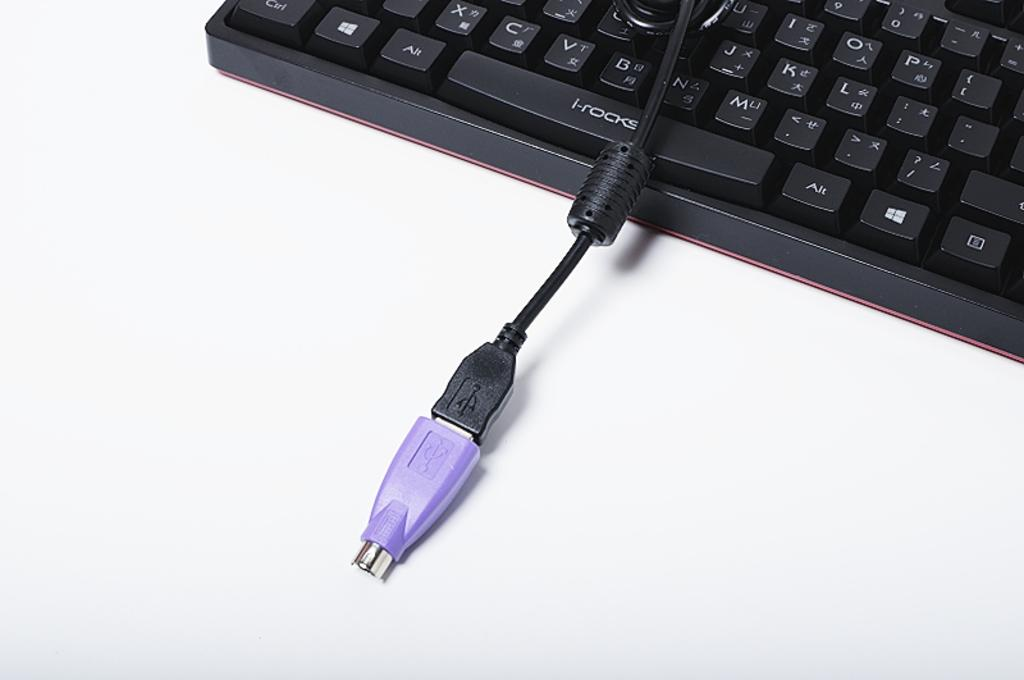<image>
Write a terse but informative summary of the picture. A black keyboard made by i-rocks that is connected to an auxiliary cable. 